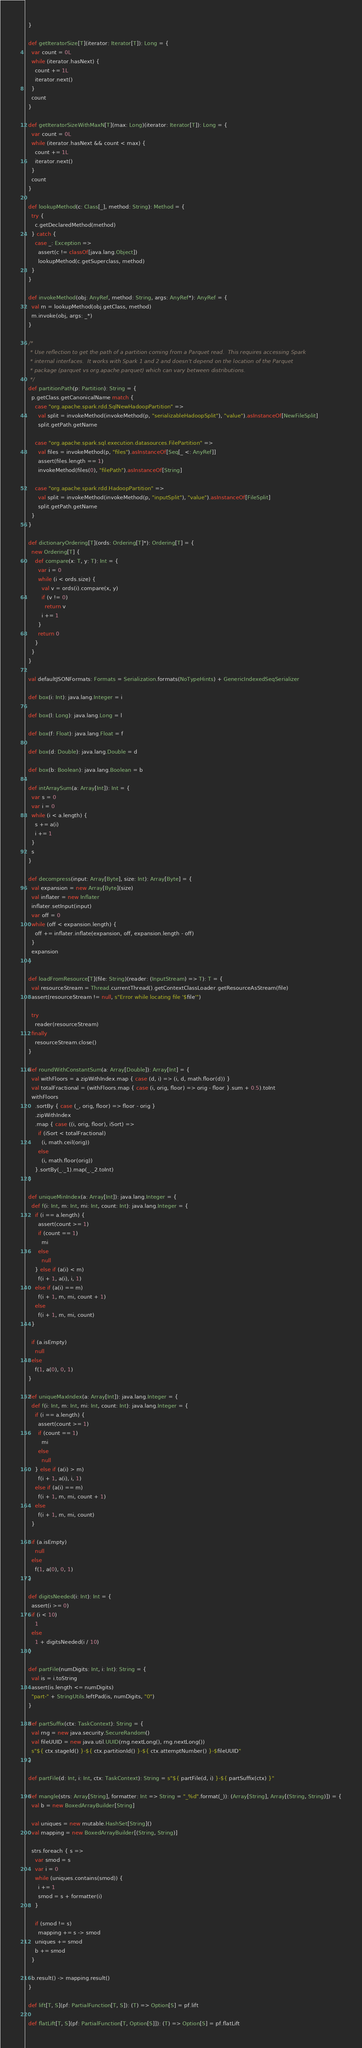<code> <loc_0><loc_0><loc_500><loc_500><_Scala_>  }

  def getIteratorSize[T](iterator: Iterator[T]): Long = {
    var count = 0L
    while (iterator.hasNext) {
      count += 1L
      iterator.next()
    }
    count
  }

  def getIteratorSizeWithMaxN[T](max: Long)(iterator: Iterator[T]): Long = {
    var count = 0L
    while (iterator.hasNext && count < max) {
      count += 1L
      iterator.next()
    }
    count
  }

  def lookupMethod(c: Class[_], method: String): Method = {
    try {
      c.getDeclaredMethod(method)
    } catch {
      case _: Exception =>
        assert(c != classOf[java.lang.Object])
        lookupMethod(c.getSuperclass, method)
    }
  }

  def invokeMethod(obj: AnyRef, method: String, args: AnyRef*): AnyRef = {
    val m = lookupMethod(obj.getClass, method)
    m.invoke(obj, args: _*)
  }

  /*
   * Use reflection to get the path of a partition coming from a Parquet read.  This requires accessing Spark
   * internal interfaces.  It works with Spark 1 and 2 and doesn't depend on the location of the Parquet
   * package (parquet vs org.apache.parquet) which can vary between distributions.
   */
  def partitionPath(p: Partition): String = {
    p.getClass.getCanonicalName match {
      case "org.apache.spark.rdd.SqlNewHadoopPartition" =>
        val split = invokeMethod(invokeMethod(p, "serializableHadoopSplit"), "value").asInstanceOf[NewFileSplit]
        split.getPath.getName

      case "org.apache.spark.sql.execution.datasources.FilePartition" =>
        val files = invokeMethod(p, "files").asInstanceOf[Seq[_ <: AnyRef]]
        assert(files.length == 1)
        invokeMethod(files(0), "filePath").asInstanceOf[String]

      case "org.apache.spark.rdd.HadoopPartition" =>
        val split = invokeMethod(invokeMethod(p, "inputSplit"), "value").asInstanceOf[FileSplit]
        split.getPath.getName
    }
  }

  def dictionaryOrdering[T](ords: Ordering[T]*): Ordering[T] = {
    new Ordering[T] {
      def compare(x: T, y: T): Int = {
        var i = 0
        while (i < ords.size) {
          val v = ords(i).compare(x, y)
          if (v != 0)
            return v
          i += 1
        }
        return 0
      }
    }
  }

  val defaultJSONFormats: Formats = Serialization.formats(NoTypeHints) + GenericIndexedSeqSerializer

  def box(i: Int): java.lang.Integer = i

  def box(l: Long): java.lang.Long = l

  def box(f: Float): java.lang.Float = f

  def box(d: Double): java.lang.Double = d

  def box(b: Boolean): java.lang.Boolean = b

  def intArraySum(a: Array[Int]): Int = {
    var s = 0
    var i = 0
    while (i < a.length) {
      s += a(i)
      i += 1
    }
    s
  }

  def decompress(input: Array[Byte], size: Int): Array[Byte] = {
    val expansion = new Array[Byte](size)
    val inflater = new Inflater
    inflater.setInput(input)
    var off = 0
    while (off < expansion.length) {
      off += inflater.inflate(expansion, off, expansion.length - off)
    }
    expansion
  }

  def loadFromResource[T](file: String)(reader: (InputStream) => T): T = {
    val resourceStream = Thread.currentThread().getContextClassLoader.getResourceAsStream(file)
    assert(resourceStream != null, s"Error while locating file '$file'")

    try
      reader(resourceStream)
    finally
      resourceStream.close()
  }

  def roundWithConstantSum(a: Array[Double]): Array[Int] = {
    val withFloors = a.zipWithIndex.map { case (d, i) => (i, d, math.floor(d)) }
    val totalFractional = (withFloors.map { case (i, orig, floor) => orig - floor }.sum + 0.5).toInt
    withFloors
      .sortBy { case (_, orig, floor) => floor - orig }
      .zipWithIndex
      .map { case ((i, orig, floor), iSort) =>
        if (iSort < totalFractional)
          (i, math.ceil(orig))
        else
          (i, math.floor(orig))
      }.sortBy(_._1).map(_._2.toInt)
  }

  def uniqueMinIndex(a: Array[Int]): java.lang.Integer = {
    def f(i: Int, m: Int, mi: Int, count: Int): java.lang.Integer = {
      if (i == a.length) {
        assert(count >= 1)
        if (count == 1)
          mi
        else
          null
      } else if (a(i) < m)
        f(i + 1, a(i), i, 1)
      else if (a(i) == m)
        f(i + 1, m, mi, count + 1)
      else
        f(i + 1, m, mi, count)
    }

    if (a.isEmpty)
      null
    else
      f(1, a(0), 0, 1)
  }

  def uniqueMaxIndex(a: Array[Int]): java.lang.Integer = {
    def f(i: Int, m: Int, mi: Int, count: Int): java.lang.Integer = {
      if (i == a.length) {
        assert(count >= 1)
        if (count == 1)
          mi
        else
          null
      } else if (a(i) > m)
        f(i + 1, a(i), i, 1)
      else if (a(i) == m)
        f(i + 1, m, mi, count + 1)
      else
        f(i + 1, m, mi, count)
    }

    if (a.isEmpty)
      null
    else
      f(1, a(0), 0, 1)
  }

  def digitsNeeded(i: Int): Int = {
    assert(i >= 0)
    if (i < 10)
      1
    else
      1 + digitsNeeded(i / 10)
  }

  def partFile(numDigits: Int, i: Int): String = {
    val is = i.toString
    assert(is.length <= numDigits)
    "part-" + StringUtils.leftPad(is, numDigits, "0")
  }

  def partSuffix(ctx: TaskContext): String = {
    val rng = new java.security.SecureRandom()
    val fileUUID = new java.util.UUID(rng.nextLong(), rng.nextLong())
    s"${ ctx.stageId() }-${ ctx.partitionId() }-${ ctx.attemptNumber() }-$fileUUID"
  }

  def partFile(d: Int, i: Int, ctx: TaskContext): String = s"${ partFile(d, i) }-${ partSuffix(ctx) }"

  def mangle(strs: Array[String], formatter: Int => String = "_%d".format(_)): (Array[String], Array[(String, String)]) = {
    val b = new BoxedArrayBuilder[String]

    val uniques = new mutable.HashSet[String]()
    val mapping = new BoxedArrayBuilder[(String, String)]

    strs.foreach { s =>
      var smod = s
      var i = 0
      while (uniques.contains(smod)) {
        i += 1
        smod = s + formatter(i)
      }

      if (smod != s)
        mapping += s -> smod
      uniques += smod
      b += smod
    }

    b.result() -> mapping.result()
  }

  def lift[T, S](pf: PartialFunction[T, S]): (T) => Option[S] = pf.lift

  def flatLift[T, S](pf: PartialFunction[T, Option[S]]): (T) => Option[S] = pf.flatLift
</code> 